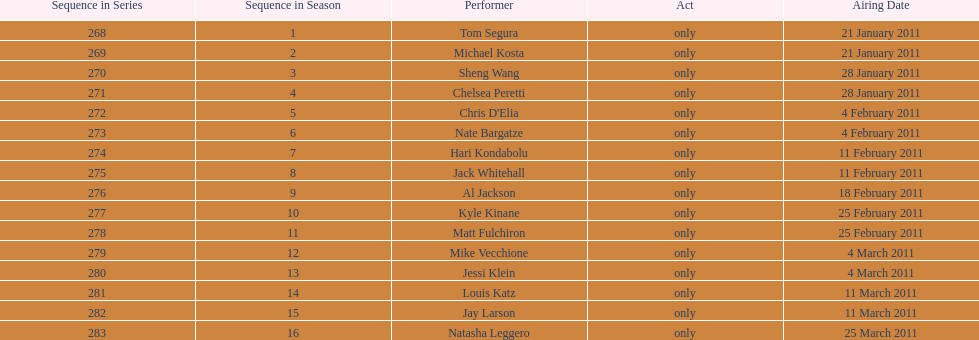Who debuted first, tom segura or jay larson? Tom Segura. 